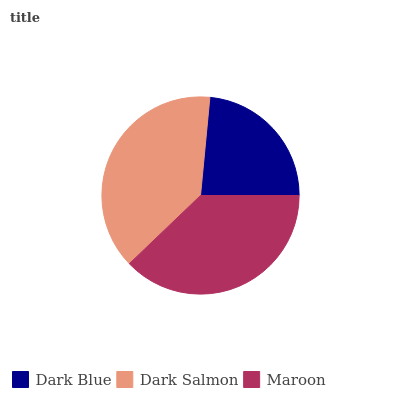Is Dark Blue the minimum?
Answer yes or no. Yes. Is Dark Salmon the maximum?
Answer yes or no. Yes. Is Maroon the minimum?
Answer yes or no. No. Is Maroon the maximum?
Answer yes or no. No. Is Dark Salmon greater than Maroon?
Answer yes or no. Yes. Is Maroon less than Dark Salmon?
Answer yes or no. Yes. Is Maroon greater than Dark Salmon?
Answer yes or no. No. Is Dark Salmon less than Maroon?
Answer yes or no. No. Is Maroon the high median?
Answer yes or no. Yes. Is Maroon the low median?
Answer yes or no. Yes. Is Dark Blue the high median?
Answer yes or no. No. Is Dark Blue the low median?
Answer yes or no. No. 